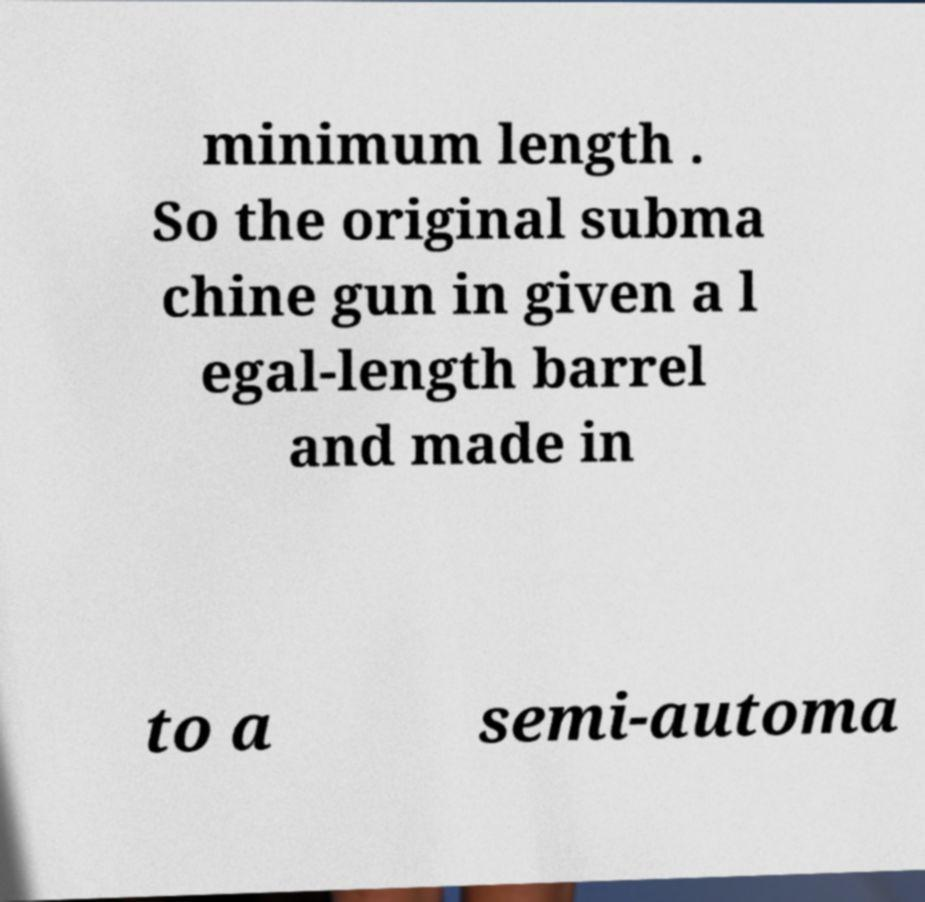Please identify and transcribe the text found in this image. minimum length . So the original subma chine gun in given a l egal-length barrel and made in to a semi-automa 